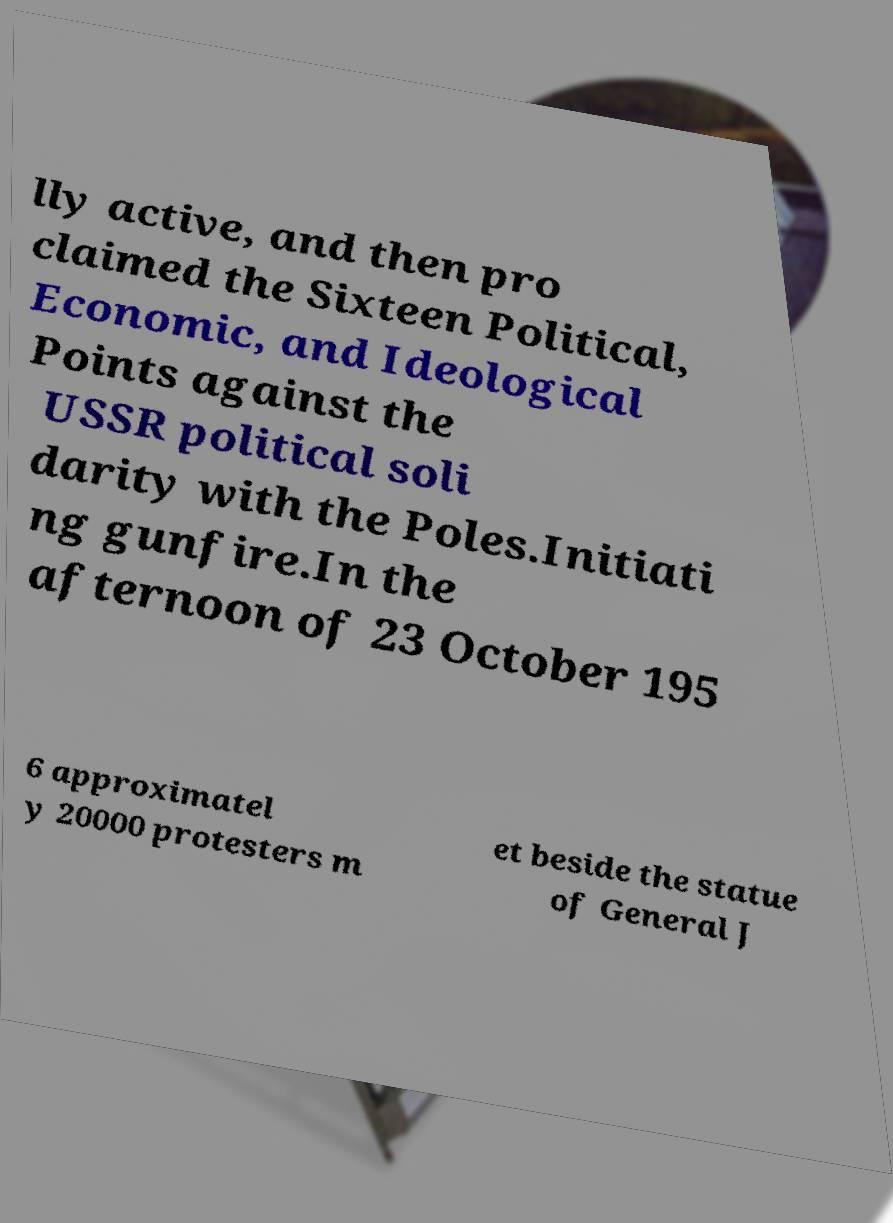Could you assist in decoding the text presented in this image and type it out clearly? lly active, and then pro claimed the Sixteen Political, Economic, and Ideological Points against the USSR political soli darity with the Poles.Initiati ng gunfire.In the afternoon of 23 October 195 6 approximatel y 20000 protesters m et beside the statue of General J 